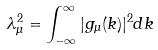<formula> <loc_0><loc_0><loc_500><loc_500>\lambda _ { \mu } ^ { 2 } = \int _ { - \infty } ^ { \infty } | g _ { \mu } ( k ) | ^ { 2 } d k \</formula> 